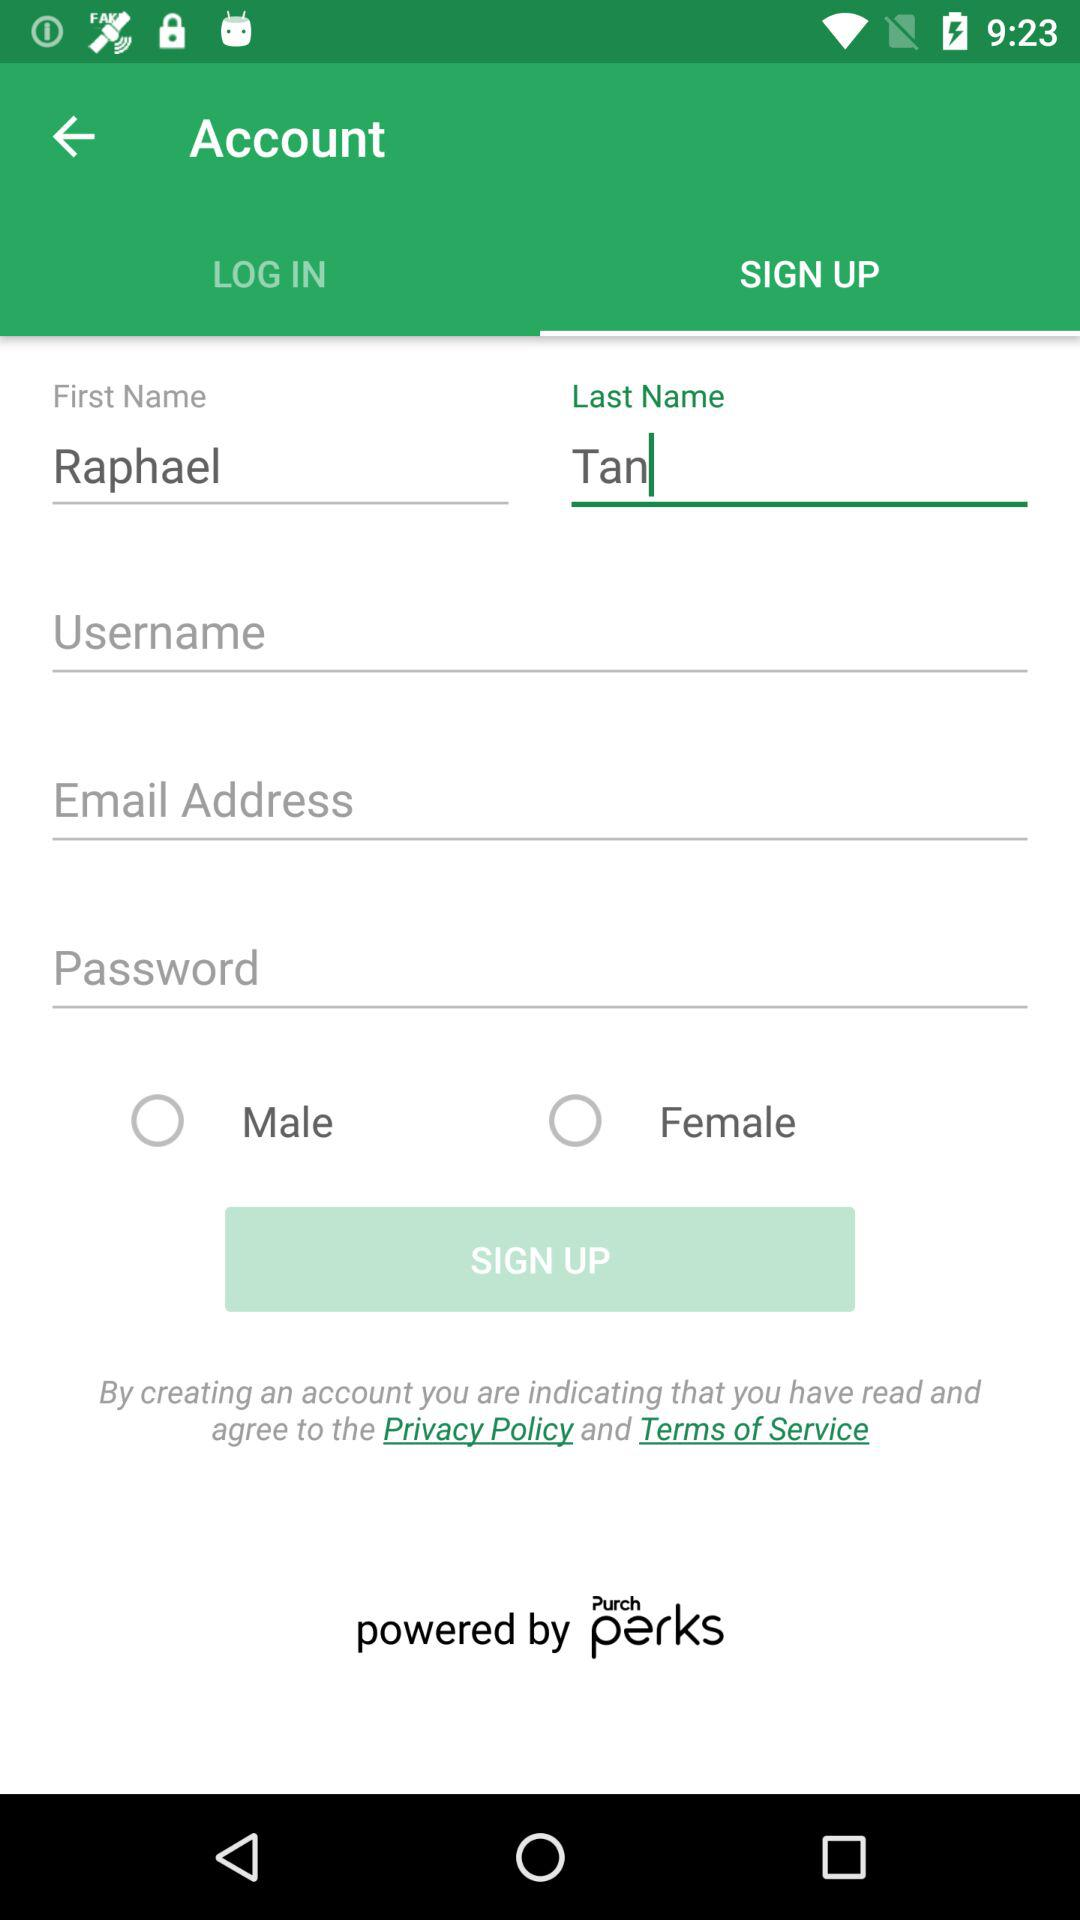What is the first name? The first name is Raphael. 